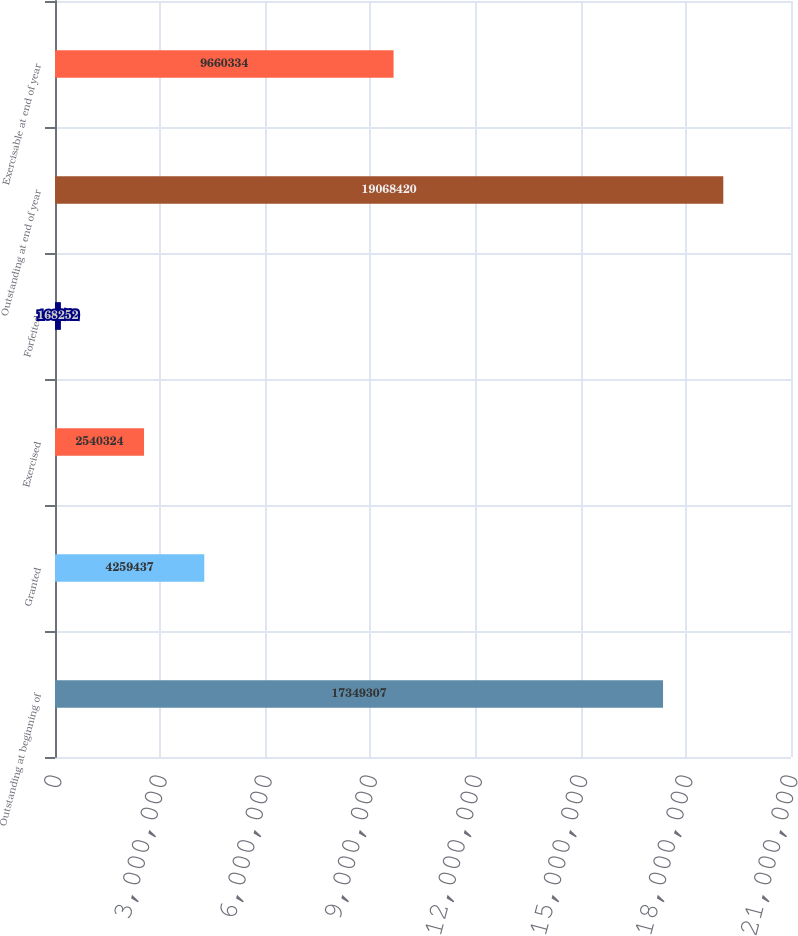Convert chart. <chart><loc_0><loc_0><loc_500><loc_500><bar_chart><fcel>Outstanding at beginning of<fcel>Granted<fcel>Exercised<fcel>Forfeited<fcel>Outstanding at end of year<fcel>Exercisable at end of year<nl><fcel>1.73493e+07<fcel>4.25944e+06<fcel>2.54032e+06<fcel>168252<fcel>1.90684e+07<fcel>9.66033e+06<nl></chart> 